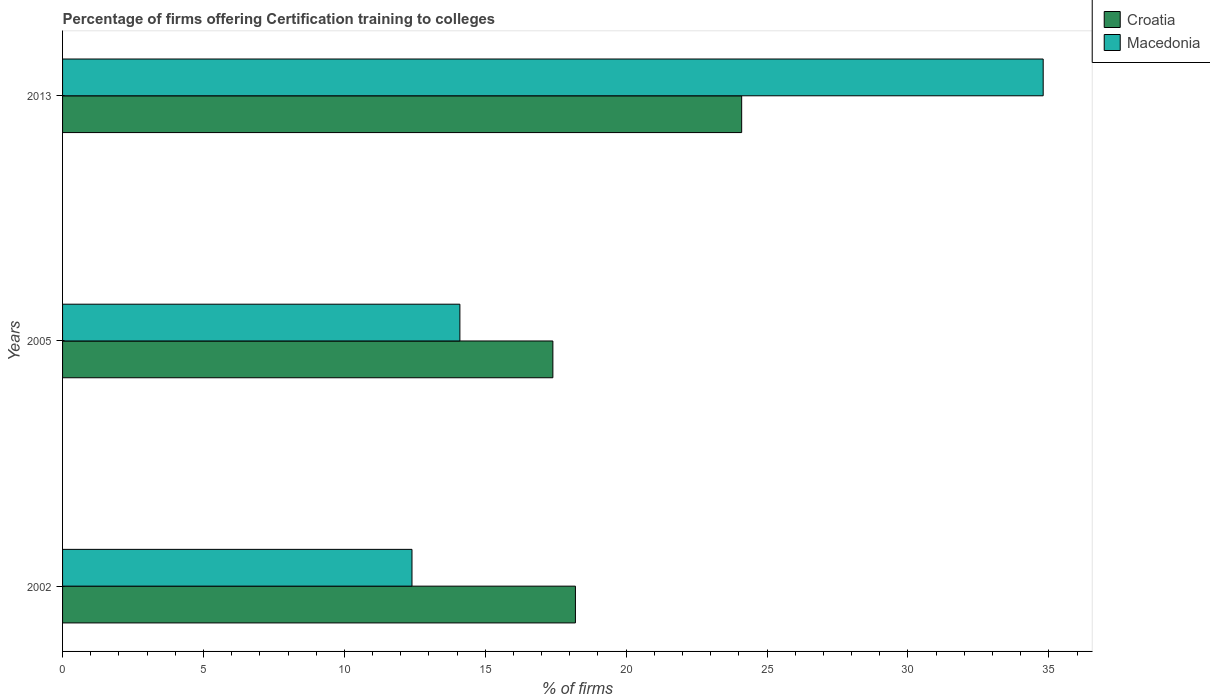How many different coloured bars are there?
Your answer should be very brief. 2. How many bars are there on the 3rd tick from the bottom?
Offer a very short reply. 2. What is the label of the 2nd group of bars from the top?
Offer a very short reply. 2005. In how many cases, is the number of bars for a given year not equal to the number of legend labels?
Provide a succinct answer. 0. What is the percentage of firms offering certification training to colleges in Macedonia in 2013?
Make the answer very short. 34.8. Across all years, what is the maximum percentage of firms offering certification training to colleges in Macedonia?
Provide a short and direct response. 34.8. Across all years, what is the minimum percentage of firms offering certification training to colleges in Macedonia?
Keep it short and to the point. 12.4. In which year was the percentage of firms offering certification training to colleges in Macedonia maximum?
Your response must be concise. 2013. In which year was the percentage of firms offering certification training to colleges in Macedonia minimum?
Make the answer very short. 2002. What is the total percentage of firms offering certification training to colleges in Macedonia in the graph?
Your answer should be very brief. 61.3. What is the difference between the percentage of firms offering certification training to colleges in Macedonia in 2002 and that in 2013?
Your answer should be compact. -22.4. What is the average percentage of firms offering certification training to colleges in Croatia per year?
Your answer should be compact. 19.9. In the year 2002, what is the difference between the percentage of firms offering certification training to colleges in Macedonia and percentage of firms offering certification training to colleges in Croatia?
Your answer should be very brief. -5.8. In how many years, is the percentage of firms offering certification training to colleges in Croatia greater than 15 %?
Make the answer very short. 3. What is the ratio of the percentage of firms offering certification training to colleges in Macedonia in 2005 to that in 2013?
Make the answer very short. 0.41. Is the percentage of firms offering certification training to colleges in Macedonia in 2002 less than that in 2013?
Provide a short and direct response. Yes. What is the difference between the highest and the second highest percentage of firms offering certification training to colleges in Macedonia?
Keep it short and to the point. 20.7. What is the difference between the highest and the lowest percentage of firms offering certification training to colleges in Macedonia?
Your answer should be compact. 22.4. Is the sum of the percentage of firms offering certification training to colleges in Croatia in 2002 and 2013 greater than the maximum percentage of firms offering certification training to colleges in Macedonia across all years?
Your response must be concise. Yes. What does the 2nd bar from the top in 2002 represents?
Offer a terse response. Croatia. What does the 1st bar from the bottom in 2013 represents?
Make the answer very short. Croatia. How many bars are there?
Provide a short and direct response. 6. Are all the bars in the graph horizontal?
Your response must be concise. Yes. What is the difference between two consecutive major ticks on the X-axis?
Provide a succinct answer. 5. Are the values on the major ticks of X-axis written in scientific E-notation?
Your answer should be very brief. No. Does the graph contain grids?
Provide a succinct answer. No. What is the title of the graph?
Make the answer very short. Percentage of firms offering Certification training to colleges. What is the label or title of the X-axis?
Offer a terse response. % of firms. What is the % of firms of Croatia in 2005?
Make the answer very short. 17.4. What is the % of firms of Macedonia in 2005?
Ensure brevity in your answer.  14.1. What is the % of firms in Croatia in 2013?
Provide a short and direct response. 24.1. What is the % of firms of Macedonia in 2013?
Offer a terse response. 34.8. Across all years, what is the maximum % of firms in Croatia?
Ensure brevity in your answer.  24.1. Across all years, what is the maximum % of firms of Macedonia?
Offer a terse response. 34.8. Across all years, what is the minimum % of firms of Croatia?
Give a very brief answer. 17.4. What is the total % of firms in Croatia in the graph?
Ensure brevity in your answer.  59.7. What is the total % of firms in Macedonia in the graph?
Give a very brief answer. 61.3. What is the difference between the % of firms in Macedonia in 2002 and that in 2013?
Your answer should be very brief. -22.4. What is the difference between the % of firms of Macedonia in 2005 and that in 2013?
Provide a succinct answer. -20.7. What is the difference between the % of firms in Croatia in 2002 and the % of firms in Macedonia in 2013?
Provide a succinct answer. -16.6. What is the difference between the % of firms of Croatia in 2005 and the % of firms of Macedonia in 2013?
Provide a succinct answer. -17.4. What is the average % of firms in Macedonia per year?
Keep it short and to the point. 20.43. In the year 2005, what is the difference between the % of firms of Croatia and % of firms of Macedonia?
Provide a short and direct response. 3.3. In the year 2013, what is the difference between the % of firms in Croatia and % of firms in Macedonia?
Provide a short and direct response. -10.7. What is the ratio of the % of firms of Croatia in 2002 to that in 2005?
Keep it short and to the point. 1.05. What is the ratio of the % of firms in Macedonia in 2002 to that in 2005?
Your answer should be very brief. 0.88. What is the ratio of the % of firms in Croatia in 2002 to that in 2013?
Your answer should be compact. 0.76. What is the ratio of the % of firms in Macedonia in 2002 to that in 2013?
Offer a terse response. 0.36. What is the ratio of the % of firms in Croatia in 2005 to that in 2013?
Provide a short and direct response. 0.72. What is the ratio of the % of firms of Macedonia in 2005 to that in 2013?
Your response must be concise. 0.41. What is the difference between the highest and the second highest % of firms of Macedonia?
Your response must be concise. 20.7. What is the difference between the highest and the lowest % of firms in Croatia?
Make the answer very short. 6.7. What is the difference between the highest and the lowest % of firms of Macedonia?
Provide a succinct answer. 22.4. 